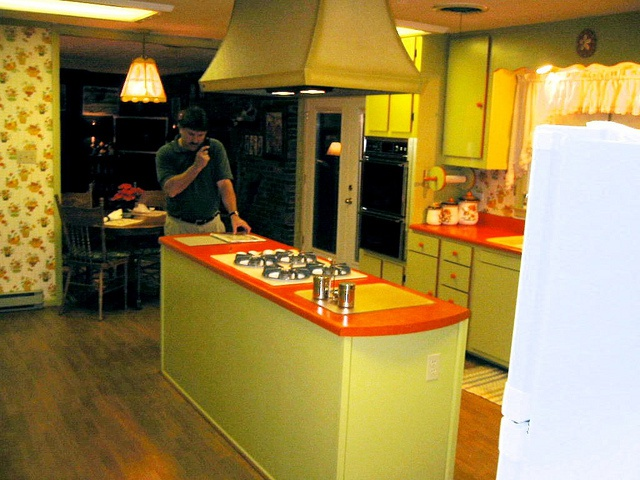Describe the objects in this image and their specific colors. I can see refrigerator in ivory, lavender, olive, and tan tones, people in ivory, black, olive, maroon, and brown tones, oven in ivory, black, darkgreen, and gray tones, chair in ivory, black, olive, and darkgreen tones, and oven in ivory, olive, khaki, and gray tones in this image. 